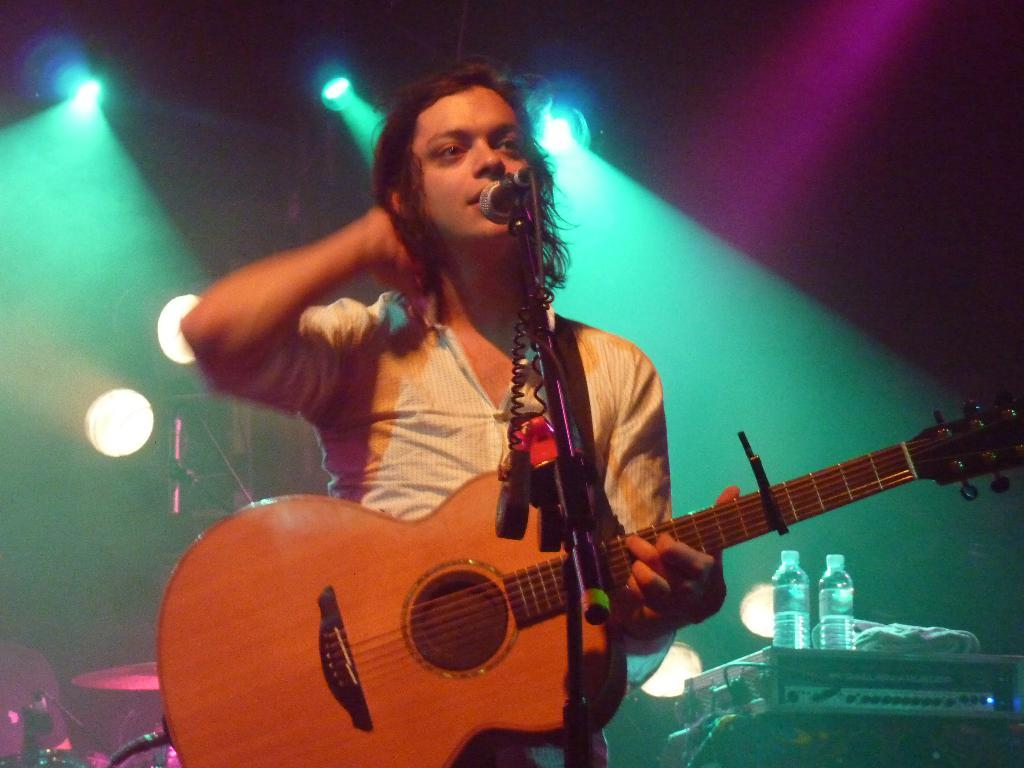What is the man in the image holding? The man is holding a guitar. What object is in front of the man? There is a microphone in front of the man. What might the man be doing in the image? The man might be playing the guitar and singing into the microphone. What type of water is being offered to the man in the image? There is no water present in the image. The man is holding a guitar and standing in front of a microphone, but there is no indication of any water being offered to him. 